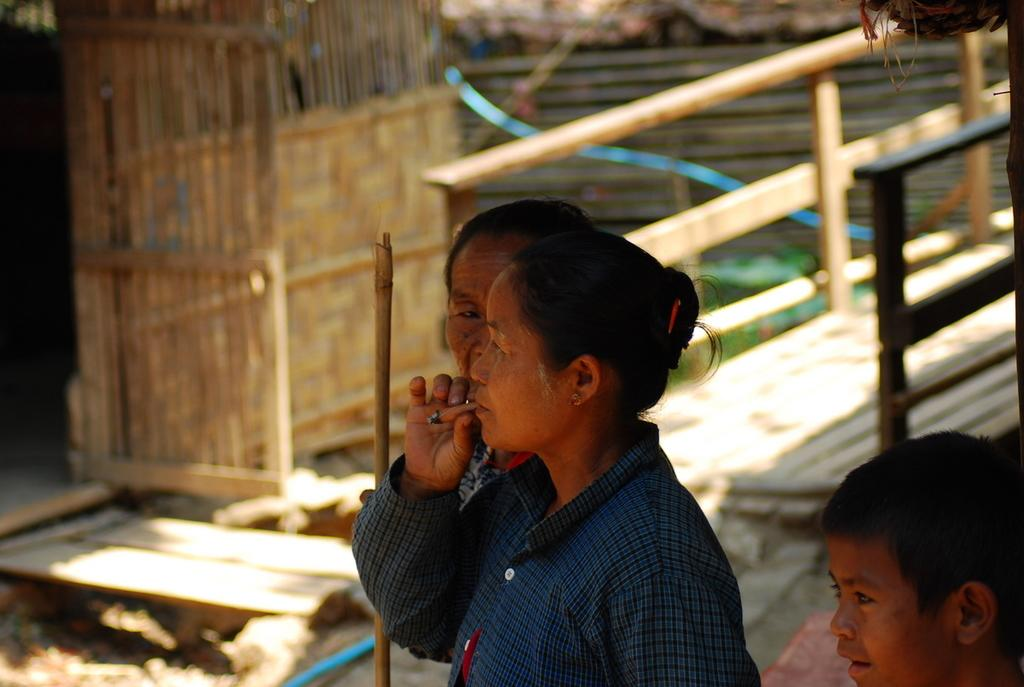What is the person holding in the image? There is a person holding an object in the image. How many other people are present in the image? There are two other people standing in the image. What type of structure can be seen in the image? There is a wooden bridge in the image, along with a wooden house. What feature is associated with the wooden bridge? There is a railing associated with the wooden bridge. What type of bean is being used as a prop in the image? There is no bean present in the image; the person is holding an unspecified object. 